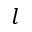<formula> <loc_0><loc_0><loc_500><loc_500>l</formula> 